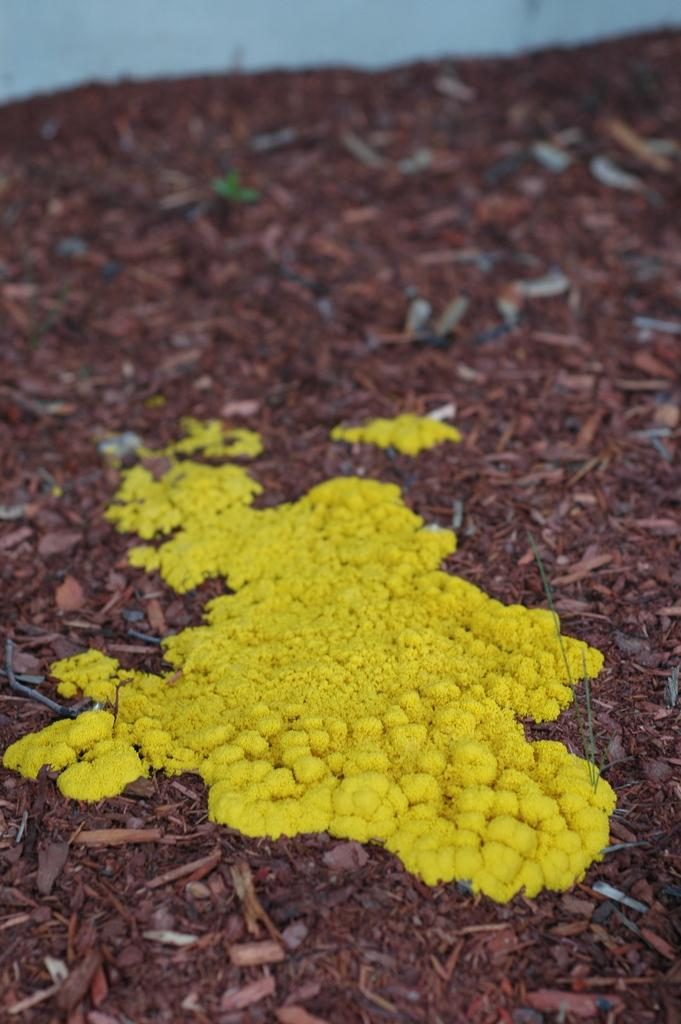What is on the ground in the foreground of the image? There is a yellow substance on the ground in the foreground of the image. What type of creature can be seen interacting with the yellow substance on the ground in the image? There is no creature present in the image; it only features a yellow substance on the ground. How many tomatoes are visible in the image? There are no tomatoes present in the image. 